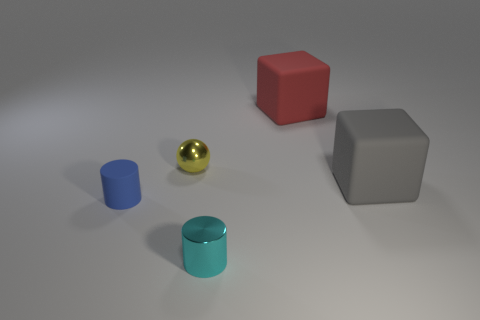Add 3 tiny blue cylinders. How many objects exist? 8 Subtract all cylinders. How many objects are left? 3 Add 4 large brown matte spheres. How many large brown matte spheres exist? 4 Subtract 0 gray cylinders. How many objects are left? 5 Subtract all tiny blue metallic cylinders. Subtract all tiny cyan metallic objects. How many objects are left? 4 Add 2 cubes. How many cubes are left? 4 